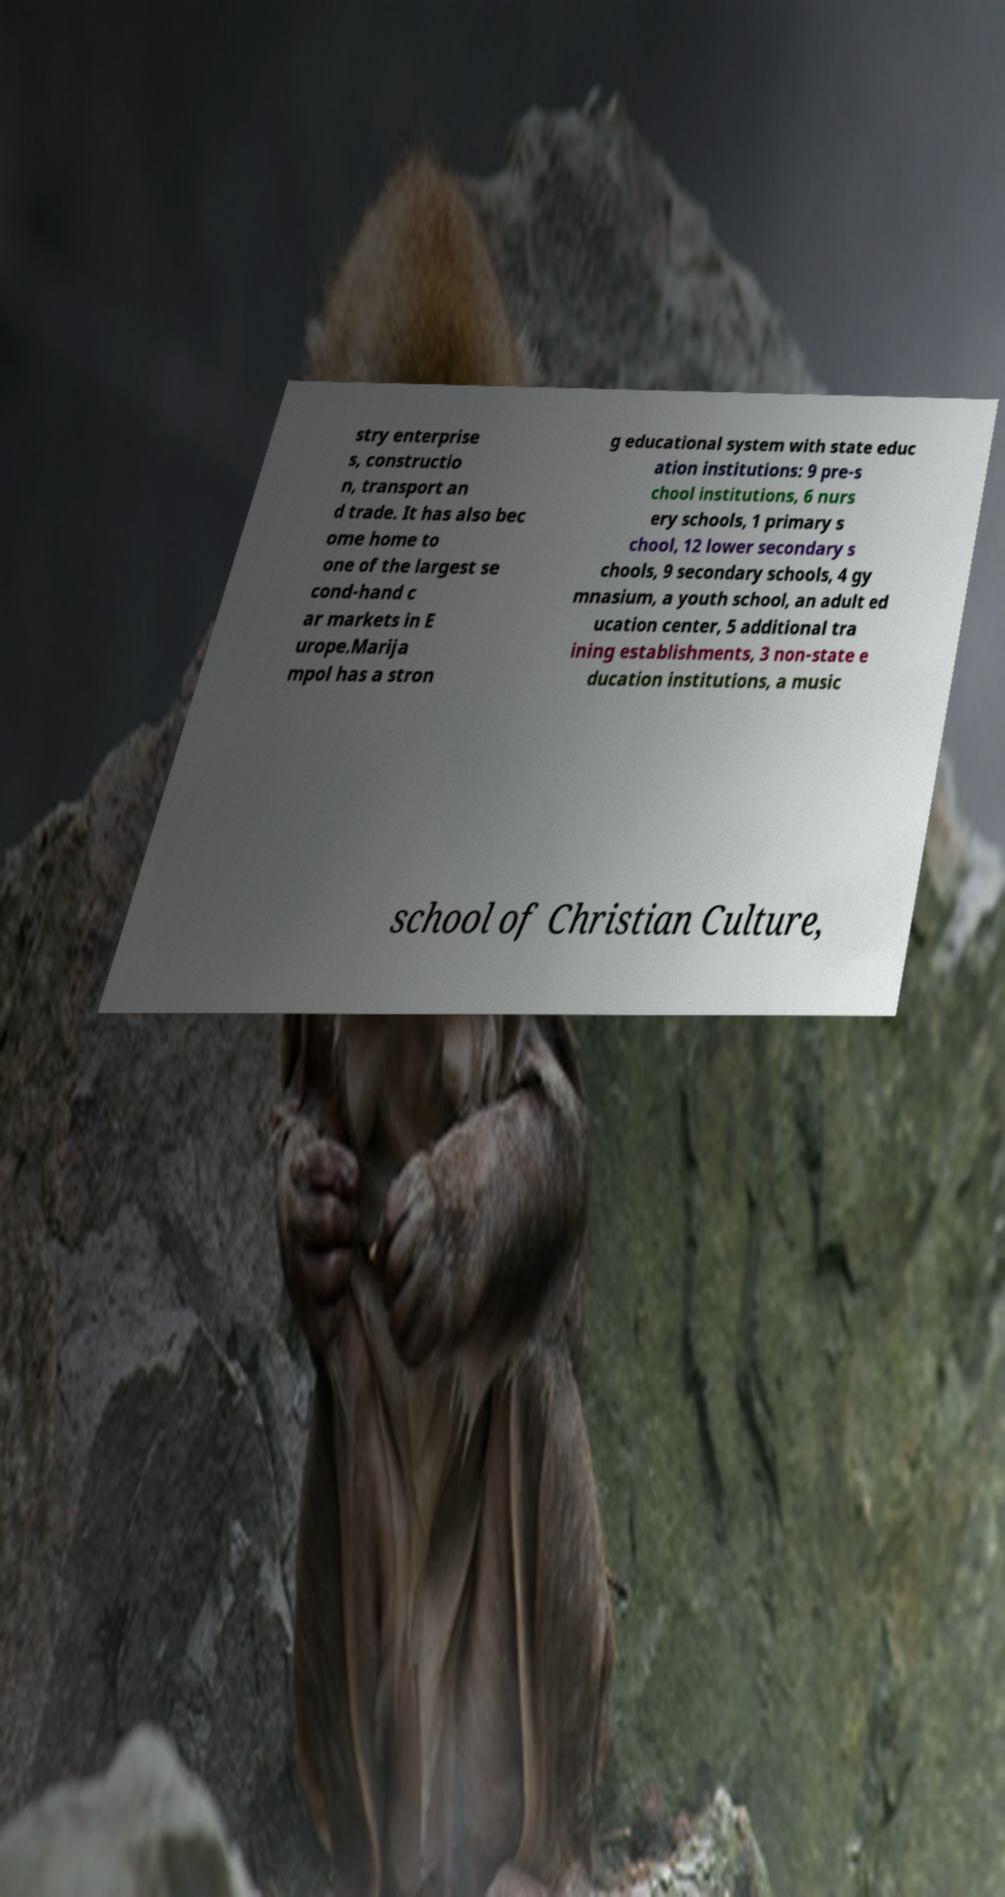Please read and relay the text visible in this image. What does it say? stry enterprise s, constructio n, transport an d trade. It has also bec ome home to one of the largest se cond-hand c ar markets in E urope.Marija mpol has a stron g educational system with state educ ation institutions: 9 pre-s chool institutions, 6 nurs ery schools, 1 primary s chool, 12 lower secondary s chools, 9 secondary schools, 4 gy mnasium, a youth school, an adult ed ucation center, 5 additional tra ining establishments, 3 non-state e ducation institutions, a music school of Christian Culture, 